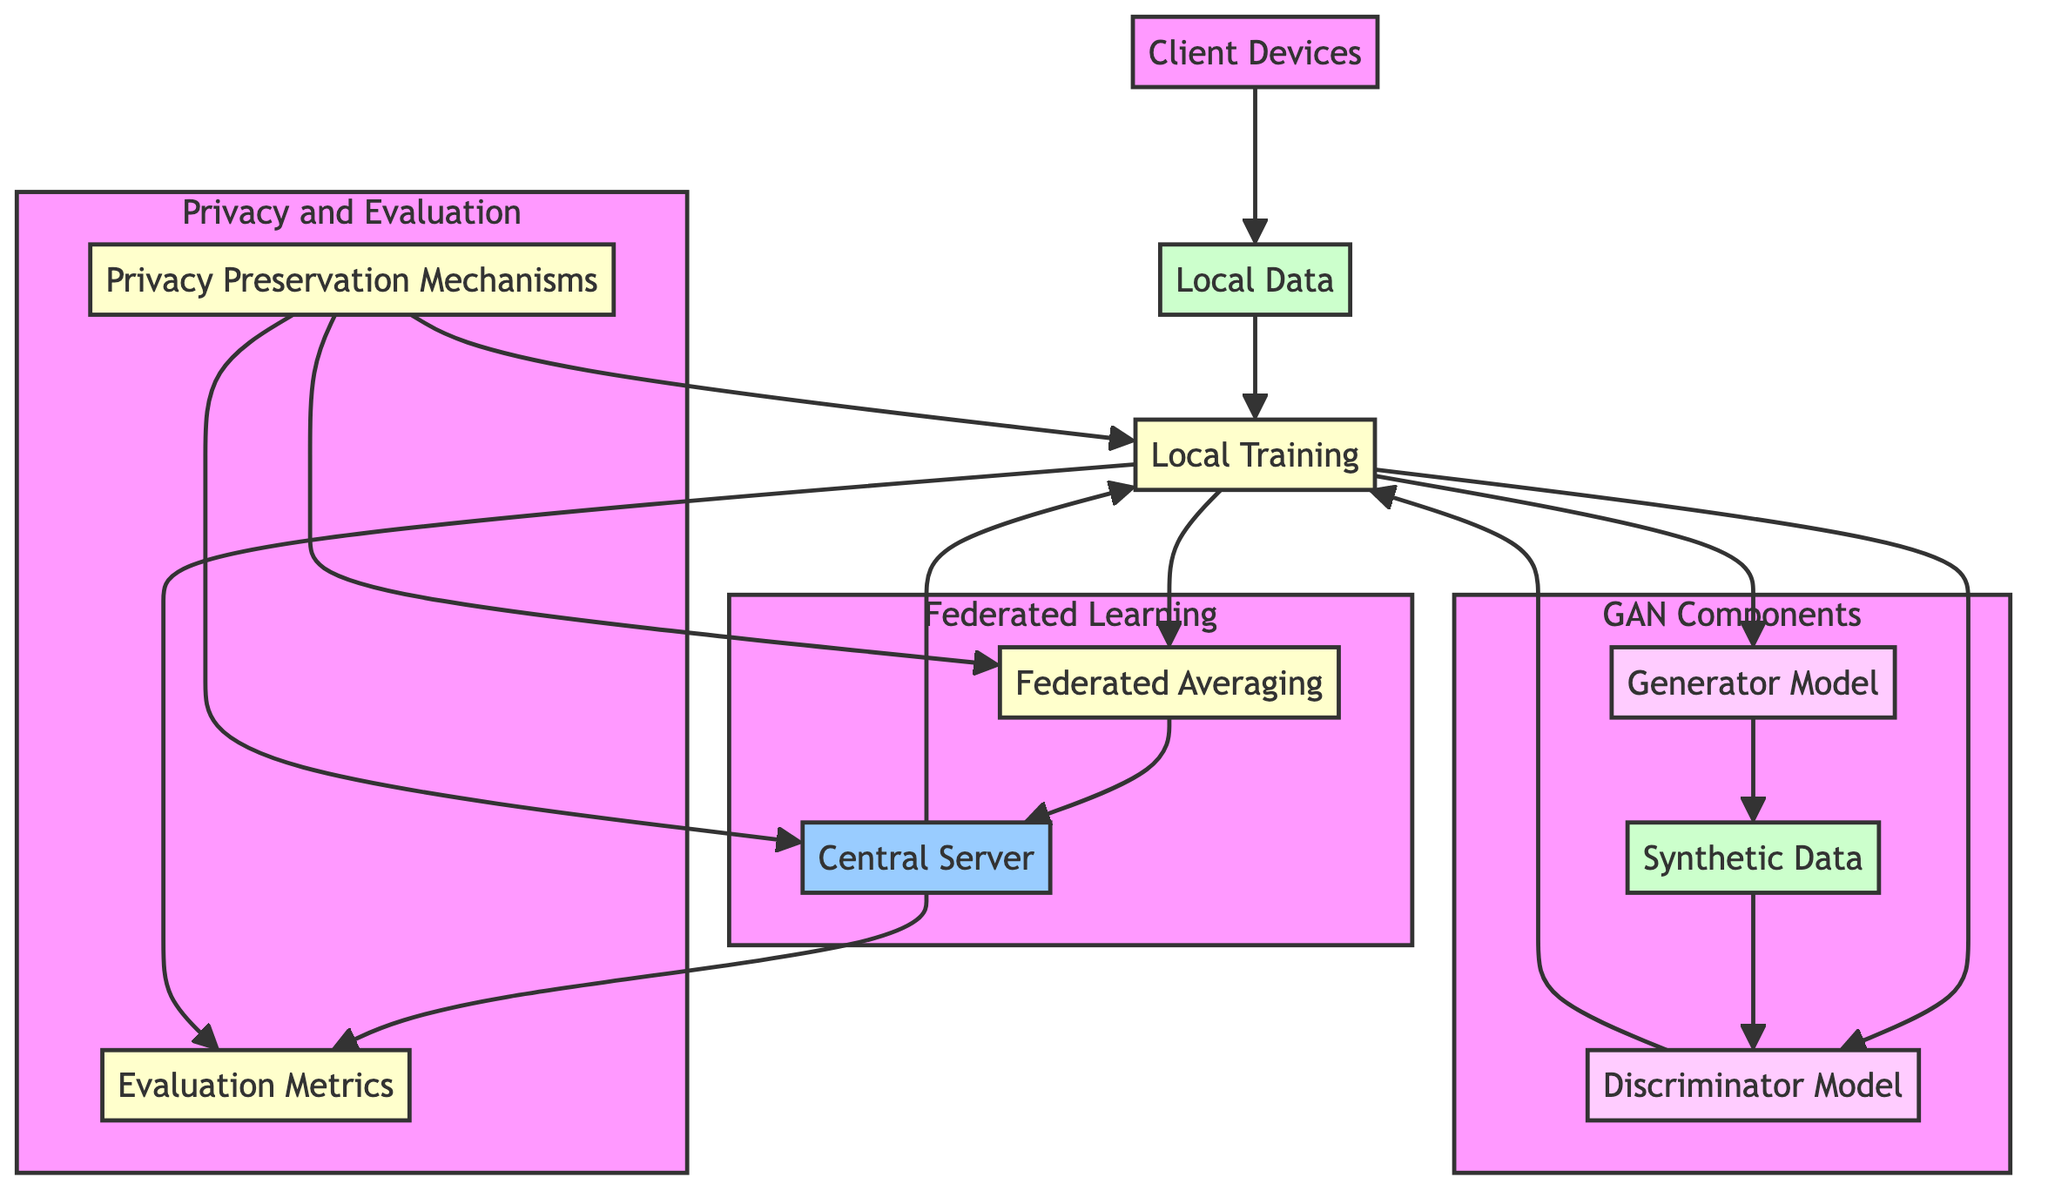What is the role of the Central Server in this diagram? The Central Server coordinates federated learning and integrates GAN components by aggregating weights and distributing the global model. It's a crucial part of maintaining the distributed learning effort.
Answer: Central entity How many elements are included in the "Federated Learning" subgraph? The "Federated Learning" subgraph includes two elements: Federated Averaging and Central Server. These elements represent the main techniques for managing the federated learning process.
Answer: 2 What is the relationship between Local Training and Synthetic Data? Local Training creates and updates data through the Generator Model to produce Synthetic Data. Feedback from the Discriminator Model is involved in improving the Local Training process.
Answer: Produces Which techniques are used for Local Training according to the diagram? The techniques associated with Local Training include Stochastic Gradient Descent and Adam Optimizer, which are standard optimization methods in training machine learning models.
Answer: Stochastic Gradient Descent, Adam Optimizer What flows into the Discriminator Model? The Discriminator Model receives input from the Synthetic Data generated by the Generator Model. This input is crucial for the Discriminator to evaluate and distinguish between real and synthetic data.
Answer: Synthetic Data How do Privacy Preservation Mechanisms interact with Local Training in the diagram? Privacy Preservation Mechanisms influence Local Training to enhance data privacy. This means the local training process is subject to privacy-enhancing methods like Differential Privacy and Homomorphic Encryption.
Answer: Enhance data privacy What are the examples listed for Local Data? The diagram mentions User Activity Logs and Sensor Readings as examples of Local Data that are generated and stored on client devices in a federated learning context.
Answer: User Activity Logs, Sensor Readings What is the output of the Generator Model? The output of the Generator Model is Synthetic Data, which is the artificially generated information used for various applications, including augmenting local datasets and preserving privacy.
Answer: Synthetic Data What links the Central Server to the Evaluation Metrics? The Central Server distributes the Global Model, which impacts the Evaluation Metrics by allowing the assessment of model performance and privacy levels based on results from each client device.
Answer: Distributes Global Model 